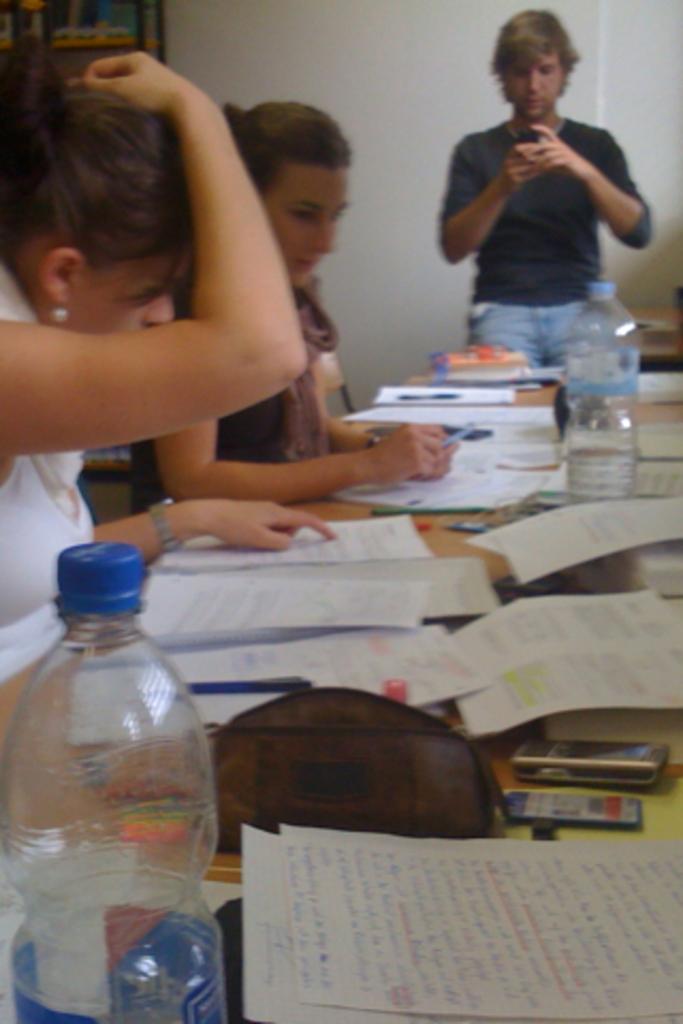Please provide a concise description of this image. Two girls are sitting in the chairs and looking into the books. A man is at the right. 